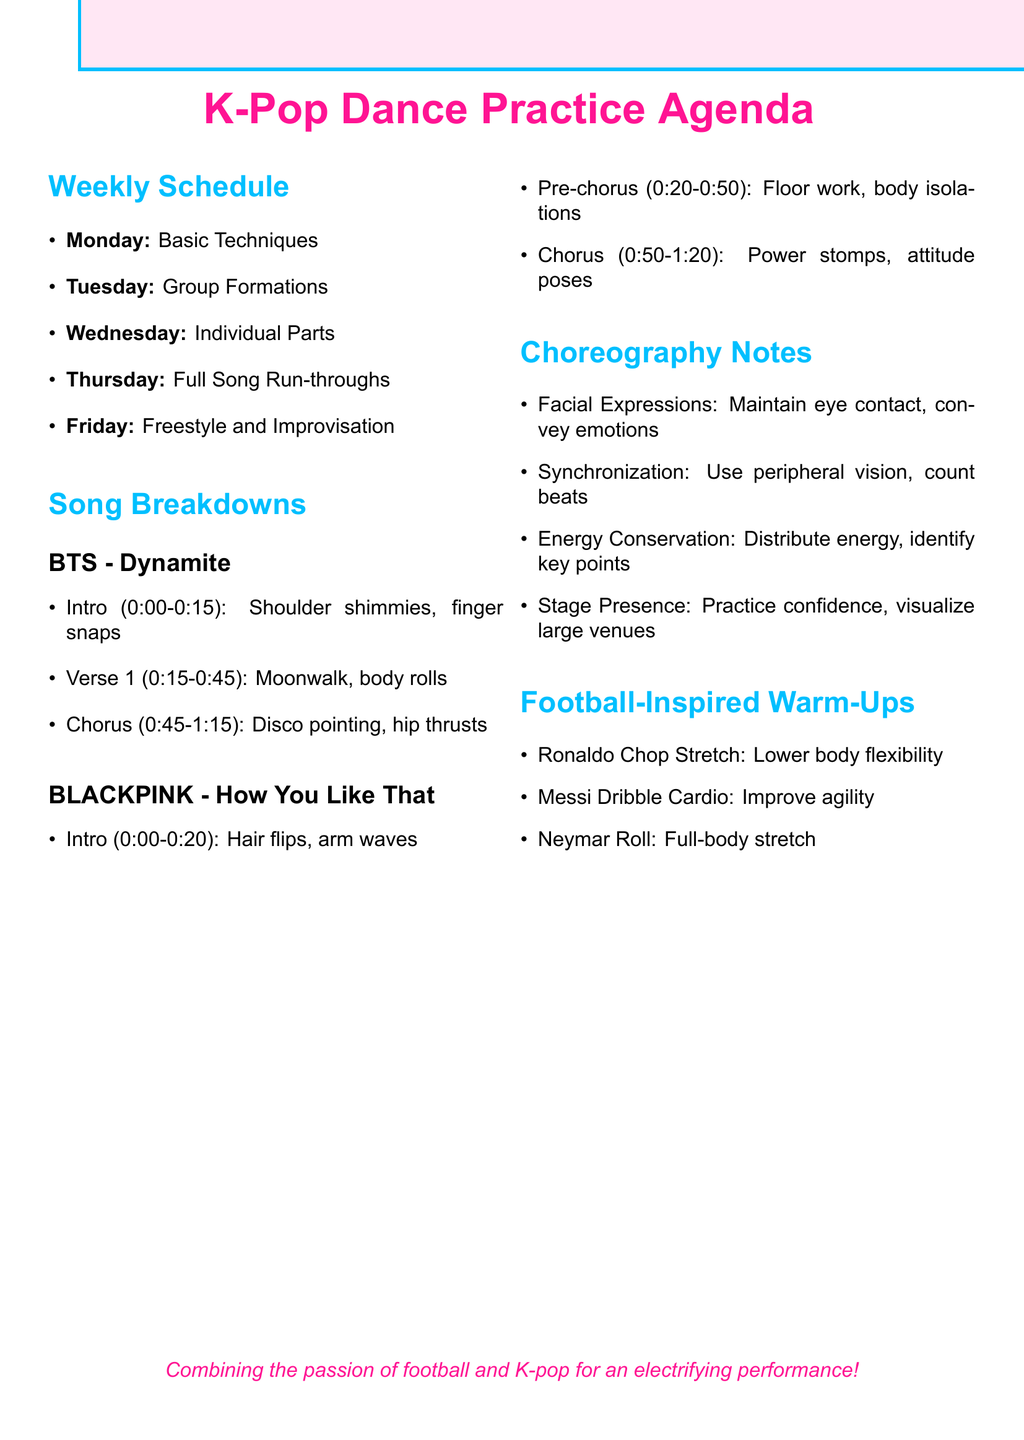What is the focus of Monday? The focus for Monday is outlined in the weekly schedule and states "Basic Techniques."
Answer: Basic Techniques What time is the practice for "Feel Special" on Tuesday? The activities for Tuesday provide specific times, with "Feel Special" practicing from 4:00 PM - 6:00 PM.
Answer: 4:00 PM - 6:00 PM What key moves are highlighted in the chorus of "Dynamite"? The song breakdown for "Dynamite" specifies key moves for the chorus as "Disco pointing, hip thrusts."
Answer: Disco pointing, hip thrusts Which choreography note emphasizes confidence? The list of choreography notes includes a section focused on confidence within the practice titled "Stage Presence."
Answer: Stage Presence How long is the freestyle session for "Fantastic Baby"? The weekly schedule indicates the duration of the freestyle session for "Fantastic Baby" as 1.5 hours, from 10:00 AM - 11:30 AM.
Answer: 1.5 hours What type of movement is practiced in the intro of "How You Like That"? The breakdown for "How You Like That" specifies that the key moves in the intro are "Hair flips, arm waves."
Answer: Hair flips, arm waves What football-inspired warm-up is focused on flexibility? Among the football-inspired warm-ups, the one that emphasizes flexibility is the "Ronaldo Chop Stretch."
Answer: Ronaldo Chop Stretch On which day is solo expression emphasized in dance practice? According to the weekly schedule, Wednesday focuses on individual parts, where expression is emphasized.
Answer: Wednesday What is described in the note about energy during performances? One of the choreography notes discusses "Energy Conservation," focusing on how to distribute energy throughout the performance.
Answer: Energy Conservation 